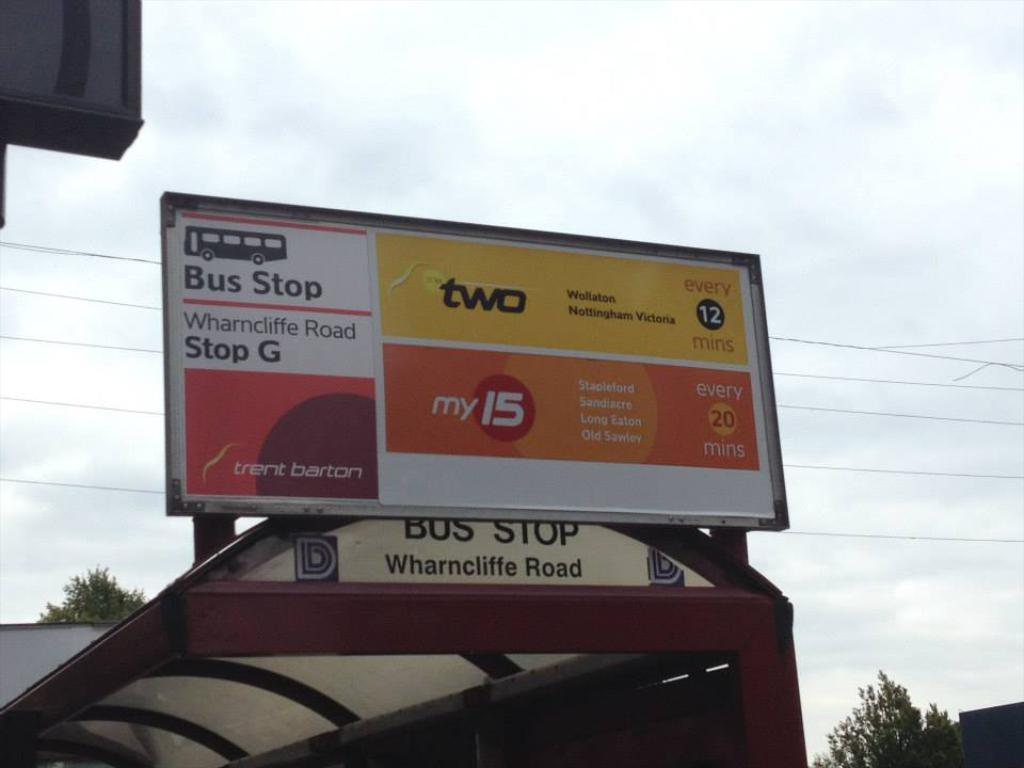Provide a one-sentence caption for the provided image. a Bus Stop for Wharncliffe Road is under a cloudy sky. 